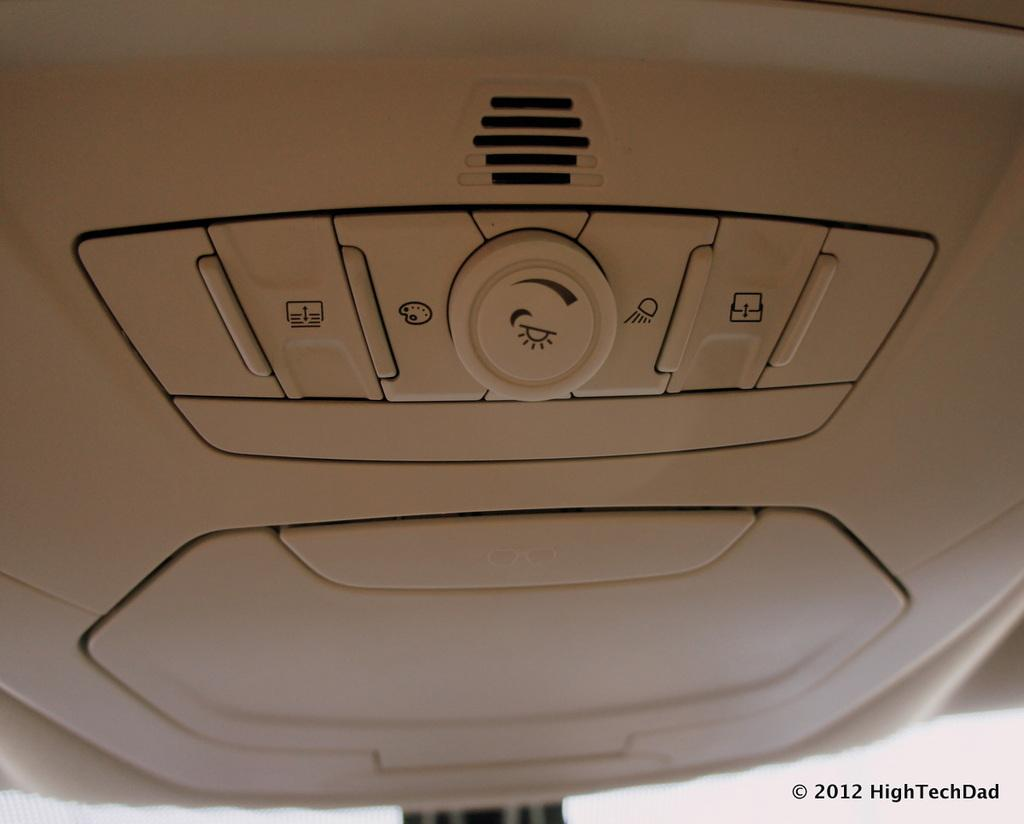What is the main subject of the image? The main subject of the image is a dashboard. What is the color of the dashboard? The dashboard is white in color. What features can be found on the dashboard? There are buttons and a knob on the dashboard. Can you see any coils on the dashboard in the image? There are no coils visible on the dashboard in the image. Is there a mask hanging from the dashboard in the image? There is no mask present on the dashboard in the image. 